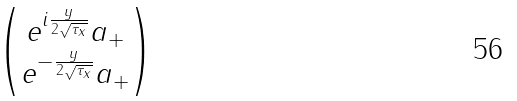<formula> <loc_0><loc_0><loc_500><loc_500>\begin{pmatrix} e ^ { i \frac { y } { 2 \sqrt { \tau _ { x } } } } a _ { + } \\ e ^ { - \frac { y } { 2 \sqrt { \tau _ { x } } } } a _ { + } \end{pmatrix}</formula> 